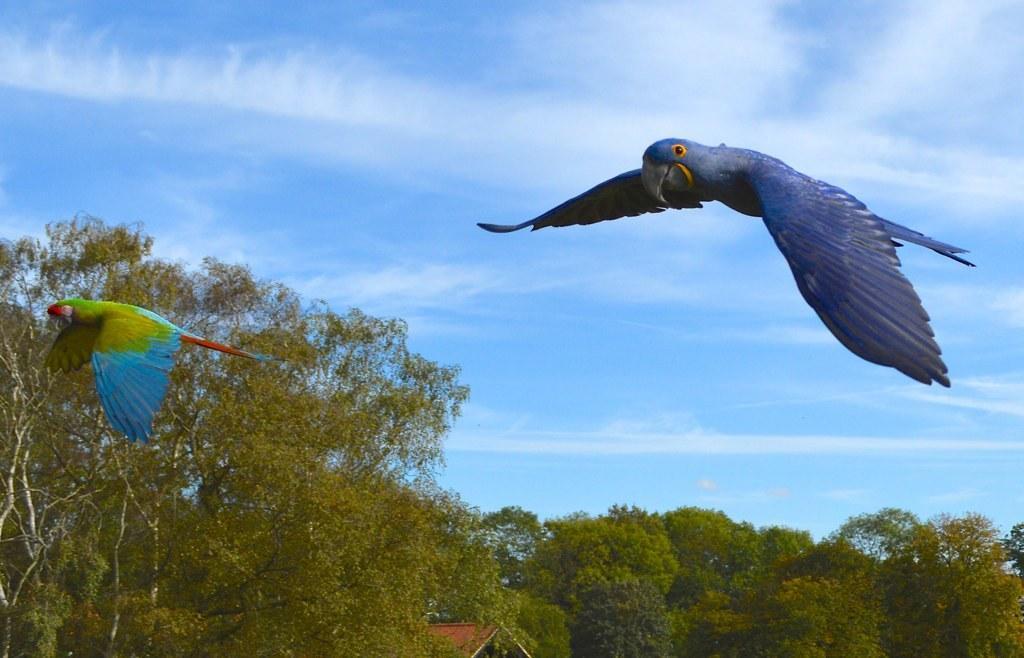In one or two sentences, can you explain what this image depicts? In the image there are birds flying in the air. Behind the birds there are many trees and also there is a roof. At the top of the image there is sky with clouds. 